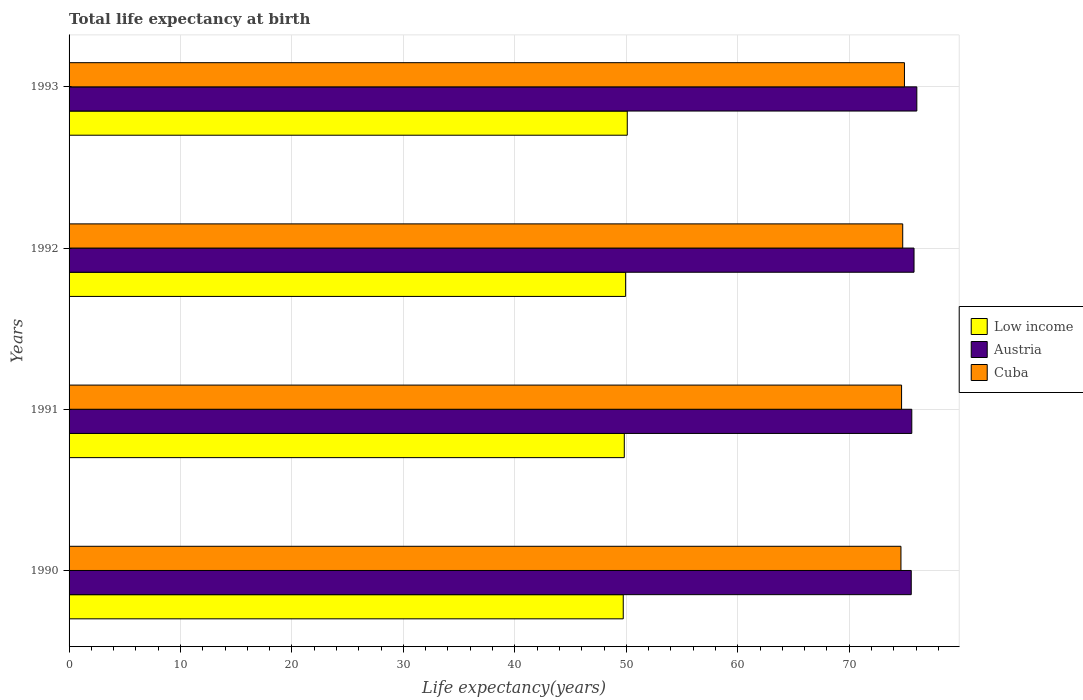How many different coloured bars are there?
Your answer should be compact. 3. Are the number of bars per tick equal to the number of legend labels?
Keep it short and to the point. Yes. Are the number of bars on each tick of the Y-axis equal?
Ensure brevity in your answer.  Yes. How many bars are there on the 3rd tick from the top?
Your answer should be very brief. 3. What is the label of the 4th group of bars from the top?
Make the answer very short. 1990. What is the life expectancy at birth in in Austria in 1990?
Make the answer very short. 75.57. Across all years, what is the maximum life expectancy at birth in in Cuba?
Ensure brevity in your answer.  74.96. Across all years, what is the minimum life expectancy at birth in in Low income?
Give a very brief answer. 49.73. What is the total life expectancy at birth in in Austria in the graph?
Make the answer very short. 303.07. What is the difference between the life expectancy at birth in in Austria in 1992 and that in 1993?
Your response must be concise. -0.25. What is the difference between the life expectancy at birth in in Cuba in 1993 and the life expectancy at birth in in Low income in 1991?
Offer a terse response. 25.14. What is the average life expectancy at birth in in Low income per year?
Your answer should be very brief. 49.89. In the year 1993, what is the difference between the life expectancy at birth in in Low income and life expectancy at birth in in Austria?
Your answer should be very brief. -25.98. In how many years, is the life expectancy at birth in in Austria greater than 18 years?
Give a very brief answer. 4. What is the ratio of the life expectancy at birth in in Austria in 1990 to that in 1991?
Give a very brief answer. 1. Is the life expectancy at birth in in Austria in 1990 less than that in 1993?
Your response must be concise. Yes. Is the difference between the life expectancy at birth in in Low income in 1991 and 1992 greater than the difference between the life expectancy at birth in in Austria in 1991 and 1992?
Provide a short and direct response. Yes. What is the difference between the highest and the second highest life expectancy at birth in in Austria?
Your response must be concise. 0.25. What is the difference between the highest and the lowest life expectancy at birth in in Austria?
Your answer should be very brief. 0.5. What does the 1st bar from the bottom in 1993 represents?
Make the answer very short. Low income. Is it the case that in every year, the sum of the life expectancy at birth in in Low income and life expectancy at birth in in Austria is greater than the life expectancy at birth in in Cuba?
Provide a succinct answer. Yes. How many bars are there?
Offer a terse response. 12. Are the values on the major ticks of X-axis written in scientific E-notation?
Ensure brevity in your answer.  No. Where does the legend appear in the graph?
Provide a succinct answer. Center right. How many legend labels are there?
Your response must be concise. 3. How are the legend labels stacked?
Provide a short and direct response. Vertical. What is the title of the graph?
Offer a terse response. Total life expectancy at birth. Does "Bahamas" appear as one of the legend labels in the graph?
Your response must be concise. No. What is the label or title of the X-axis?
Make the answer very short. Life expectancy(years). What is the label or title of the Y-axis?
Give a very brief answer. Years. What is the Life expectancy(years) of Low income in 1990?
Ensure brevity in your answer.  49.73. What is the Life expectancy(years) of Austria in 1990?
Offer a terse response. 75.57. What is the Life expectancy(years) of Cuba in 1990?
Provide a succinct answer. 74.64. What is the Life expectancy(years) in Low income in 1991?
Make the answer very short. 49.82. What is the Life expectancy(years) of Austria in 1991?
Your answer should be very brief. 75.62. What is the Life expectancy(years) of Cuba in 1991?
Keep it short and to the point. 74.7. What is the Life expectancy(years) of Low income in 1992?
Your response must be concise. 49.94. What is the Life expectancy(years) of Austria in 1992?
Make the answer very short. 75.82. What is the Life expectancy(years) in Cuba in 1992?
Provide a short and direct response. 74.8. What is the Life expectancy(years) of Low income in 1993?
Make the answer very short. 50.09. What is the Life expectancy(years) of Austria in 1993?
Offer a terse response. 76.07. What is the Life expectancy(years) of Cuba in 1993?
Provide a succinct answer. 74.96. Across all years, what is the maximum Life expectancy(years) in Low income?
Provide a succinct answer. 50.09. Across all years, what is the maximum Life expectancy(years) of Austria?
Provide a succinct answer. 76.07. Across all years, what is the maximum Life expectancy(years) of Cuba?
Ensure brevity in your answer.  74.96. Across all years, what is the minimum Life expectancy(years) of Low income?
Your response must be concise. 49.73. Across all years, what is the minimum Life expectancy(years) in Austria?
Offer a terse response. 75.57. Across all years, what is the minimum Life expectancy(years) of Cuba?
Provide a succinct answer. 74.64. What is the total Life expectancy(years) in Low income in the graph?
Offer a very short reply. 199.57. What is the total Life expectancy(years) in Austria in the graph?
Give a very brief answer. 303.07. What is the total Life expectancy(years) in Cuba in the graph?
Provide a short and direct response. 299.11. What is the difference between the Life expectancy(years) of Low income in 1990 and that in 1991?
Make the answer very short. -0.09. What is the difference between the Life expectancy(years) in Austria in 1990 and that in 1991?
Ensure brevity in your answer.  -0.05. What is the difference between the Life expectancy(years) of Cuba in 1990 and that in 1991?
Provide a succinct answer. -0.06. What is the difference between the Life expectancy(years) in Low income in 1990 and that in 1992?
Give a very brief answer. -0.21. What is the difference between the Life expectancy(years) in Austria in 1990 and that in 1992?
Your response must be concise. -0.25. What is the difference between the Life expectancy(years) of Cuba in 1990 and that in 1992?
Your response must be concise. -0.16. What is the difference between the Life expectancy(years) of Low income in 1990 and that in 1993?
Provide a short and direct response. -0.36. What is the difference between the Life expectancy(years) of Cuba in 1990 and that in 1993?
Give a very brief answer. -0.32. What is the difference between the Life expectancy(years) in Low income in 1991 and that in 1992?
Give a very brief answer. -0.12. What is the difference between the Life expectancy(years) in Cuba in 1991 and that in 1992?
Make the answer very short. -0.1. What is the difference between the Life expectancy(years) in Low income in 1991 and that in 1993?
Your answer should be very brief. -0.27. What is the difference between the Life expectancy(years) of Austria in 1991 and that in 1993?
Keep it short and to the point. -0.45. What is the difference between the Life expectancy(years) in Cuba in 1991 and that in 1993?
Make the answer very short. -0.26. What is the difference between the Life expectancy(years) of Low income in 1992 and that in 1993?
Make the answer very short. -0.15. What is the difference between the Life expectancy(years) of Austria in 1992 and that in 1993?
Ensure brevity in your answer.  -0.25. What is the difference between the Life expectancy(years) of Cuba in 1992 and that in 1993?
Offer a very short reply. -0.16. What is the difference between the Life expectancy(years) of Low income in 1990 and the Life expectancy(years) of Austria in 1991?
Your answer should be compact. -25.89. What is the difference between the Life expectancy(years) in Low income in 1990 and the Life expectancy(years) in Cuba in 1991?
Offer a very short reply. -24.98. What is the difference between the Life expectancy(years) of Austria in 1990 and the Life expectancy(years) of Cuba in 1991?
Your answer should be compact. 0.87. What is the difference between the Life expectancy(years) of Low income in 1990 and the Life expectancy(years) of Austria in 1992?
Keep it short and to the point. -26.09. What is the difference between the Life expectancy(years) in Low income in 1990 and the Life expectancy(years) in Cuba in 1992?
Give a very brief answer. -25.08. What is the difference between the Life expectancy(years) of Austria in 1990 and the Life expectancy(years) of Cuba in 1992?
Make the answer very short. 0.77. What is the difference between the Life expectancy(years) in Low income in 1990 and the Life expectancy(years) in Austria in 1993?
Keep it short and to the point. -26.34. What is the difference between the Life expectancy(years) in Low income in 1990 and the Life expectancy(years) in Cuba in 1993?
Give a very brief answer. -25.23. What is the difference between the Life expectancy(years) of Austria in 1990 and the Life expectancy(years) of Cuba in 1993?
Provide a short and direct response. 0.61. What is the difference between the Life expectancy(years) of Low income in 1991 and the Life expectancy(years) of Austria in 1992?
Give a very brief answer. -26. What is the difference between the Life expectancy(years) of Low income in 1991 and the Life expectancy(years) of Cuba in 1992?
Your answer should be very brief. -24.98. What is the difference between the Life expectancy(years) in Austria in 1991 and the Life expectancy(years) in Cuba in 1992?
Provide a short and direct response. 0.81. What is the difference between the Life expectancy(years) of Low income in 1991 and the Life expectancy(years) of Austria in 1993?
Your response must be concise. -26.25. What is the difference between the Life expectancy(years) in Low income in 1991 and the Life expectancy(years) in Cuba in 1993?
Your answer should be compact. -25.14. What is the difference between the Life expectancy(years) of Austria in 1991 and the Life expectancy(years) of Cuba in 1993?
Keep it short and to the point. 0.66. What is the difference between the Life expectancy(years) of Low income in 1992 and the Life expectancy(years) of Austria in 1993?
Offer a very short reply. -26.13. What is the difference between the Life expectancy(years) in Low income in 1992 and the Life expectancy(years) in Cuba in 1993?
Ensure brevity in your answer.  -25.02. What is the difference between the Life expectancy(years) of Austria in 1992 and the Life expectancy(years) of Cuba in 1993?
Provide a short and direct response. 0.86. What is the average Life expectancy(years) in Low income per year?
Give a very brief answer. 49.89. What is the average Life expectancy(years) in Austria per year?
Your answer should be compact. 75.77. What is the average Life expectancy(years) of Cuba per year?
Ensure brevity in your answer.  74.78. In the year 1990, what is the difference between the Life expectancy(years) in Low income and Life expectancy(years) in Austria?
Ensure brevity in your answer.  -25.84. In the year 1990, what is the difference between the Life expectancy(years) of Low income and Life expectancy(years) of Cuba?
Offer a terse response. -24.92. In the year 1990, what is the difference between the Life expectancy(years) of Austria and Life expectancy(years) of Cuba?
Offer a terse response. 0.92. In the year 1991, what is the difference between the Life expectancy(years) in Low income and Life expectancy(years) in Austria?
Offer a very short reply. -25.8. In the year 1991, what is the difference between the Life expectancy(years) in Low income and Life expectancy(years) in Cuba?
Provide a short and direct response. -24.88. In the year 1991, what is the difference between the Life expectancy(years) in Austria and Life expectancy(years) in Cuba?
Ensure brevity in your answer.  0.92. In the year 1992, what is the difference between the Life expectancy(years) in Low income and Life expectancy(years) in Austria?
Provide a succinct answer. -25.88. In the year 1992, what is the difference between the Life expectancy(years) in Low income and Life expectancy(years) in Cuba?
Offer a very short reply. -24.86. In the year 1992, what is the difference between the Life expectancy(years) in Austria and Life expectancy(years) in Cuba?
Make the answer very short. 1.01. In the year 1993, what is the difference between the Life expectancy(years) of Low income and Life expectancy(years) of Austria?
Your answer should be compact. -25.98. In the year 1993, what is the difference between the Life expectancy(years) in Low income and Life expectancy(years) in Cuba?
Keep it short and to the point. -24.87. In the year 1993, what is the difference between the Life expectancy(years) of Austria and Life expectancy(years) of Cuba?
Offer a very short reply. 1.11. What is the ratio of the Life expectancy(years) in Low income in 1990 to that in 1991?
Give a very brief answer. 1. What is the ratio of the Life expectancy(years) of Austria in 1990 to that in 1991?
Keep it short and to the point. 1. What is the ratio of the Life expectancy(years) in Cuba in 1990 to that in 1991?
Provide a short and direct response. 1. What is the ratio of the Life expectancy(years) in Austria in 1990 to that in 1992?
Your response must be concise. 1. What is the ratio of the Life expectancy(years) in Cuba in 1990 to that in 1992?
Offer a terse response. 1. What is the ratio of the Life expectancy(years) in Austria in 1990 to that in 1993?
Ensure brevity in your answer.  0.99. What is the ratio of the Life expectancy(years) in Low income in 1991 to that in 1992?
Provide a short and direct response. 1. What is the ratio of the Life expectancy(years) in Cuba in 1992 to that in 1993?
Your answer should be compact. 1. What is the difference between the highest and the second highest Life expectancy(years) of Low income?
Your answer should be compact. 0.15. What is the difference between the highest and the second highest Life expectancy(years) in Austria?
Your answer should be very brief. 0.25. What is the difference between the highest and the second highest Life expectancy(years) of Cuba?
Provide a short and direct response. 0.16. What is the difference between the highest and the lowest Life expectancy(years) in Low income?
Provide a short and direct response. 0.36. What is the difference between the highest and the lowest Life expectancy(years) in Cuba?
Provide a short and direct response. 0.32. 